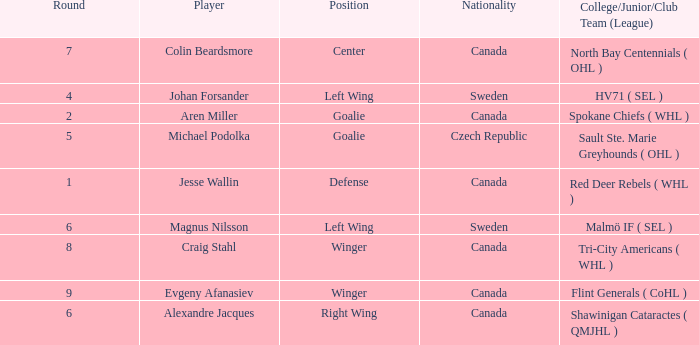What is the Nationality for alexandre jacques? Canada. 